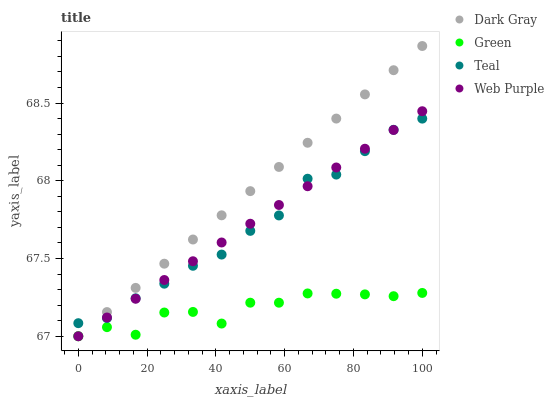Does Green have the minimum area under the curve?
Answer yes or no. Yes. Does Dark Gray have the maximum area under the curve?
Answer yes or no. Yes. Does Web Purple have the minimum area under the curve?
Answer yes or no. No. Does Web Purple have the maximum area under the curve?
Answer yes or no. No. Is Web Purple the smoothest?
Answer yes or no. Yes. Is Green the roughest?
Answer yes or no. Yes. Is Green the smoothest?
Answer yes or no. No. Is Web Purple the roughest?
Answer yes or no. No. Does Dark Gray have the lowest value?
Answer yes or no. Yes. Does Teal have the lowest value?
Answer yes or no. No. Does Dark Gray have the highest value?
Answer yes or no. Yes. Does Web Purple have the highest value?
Answer yes or no. No. Is Green less than Teal?
Answer yes or no. Yes. Is Teal greater than Green?
Answer yes or no. Yes. Does Teal intersect Web Purple?
Answer yes or no. Yes. Is Teal less than Web Purple?
Answer yes or no. No. Is Teal greater than Web Purple?
Answer yes or no. No. Does Green intersect Teal?
Answer yes or no. No. 